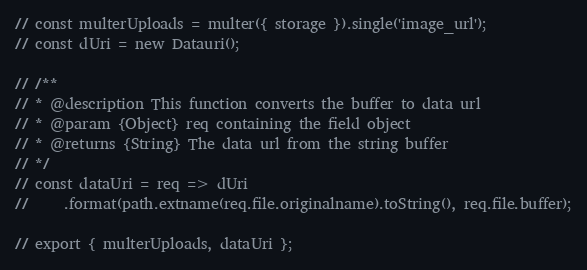Convert code to text. <code><loc_0><loc_0><loc_500><loc_500><_JavaScript_>// const multerUploads = multer({ storage }).single('image_url');
// const dUri = new Datauri();

// /**
// * @description This function converts the buffer to data url
// * @param {Object} req containing the field object
// * @returns {String} The data url from the string buffer
// */
// const dataUri = req => dUri
//     .format(path.extname(req.file.originalname).toString(), req.file.buffer);

// export { multerUploads, dataUri };
</code> 